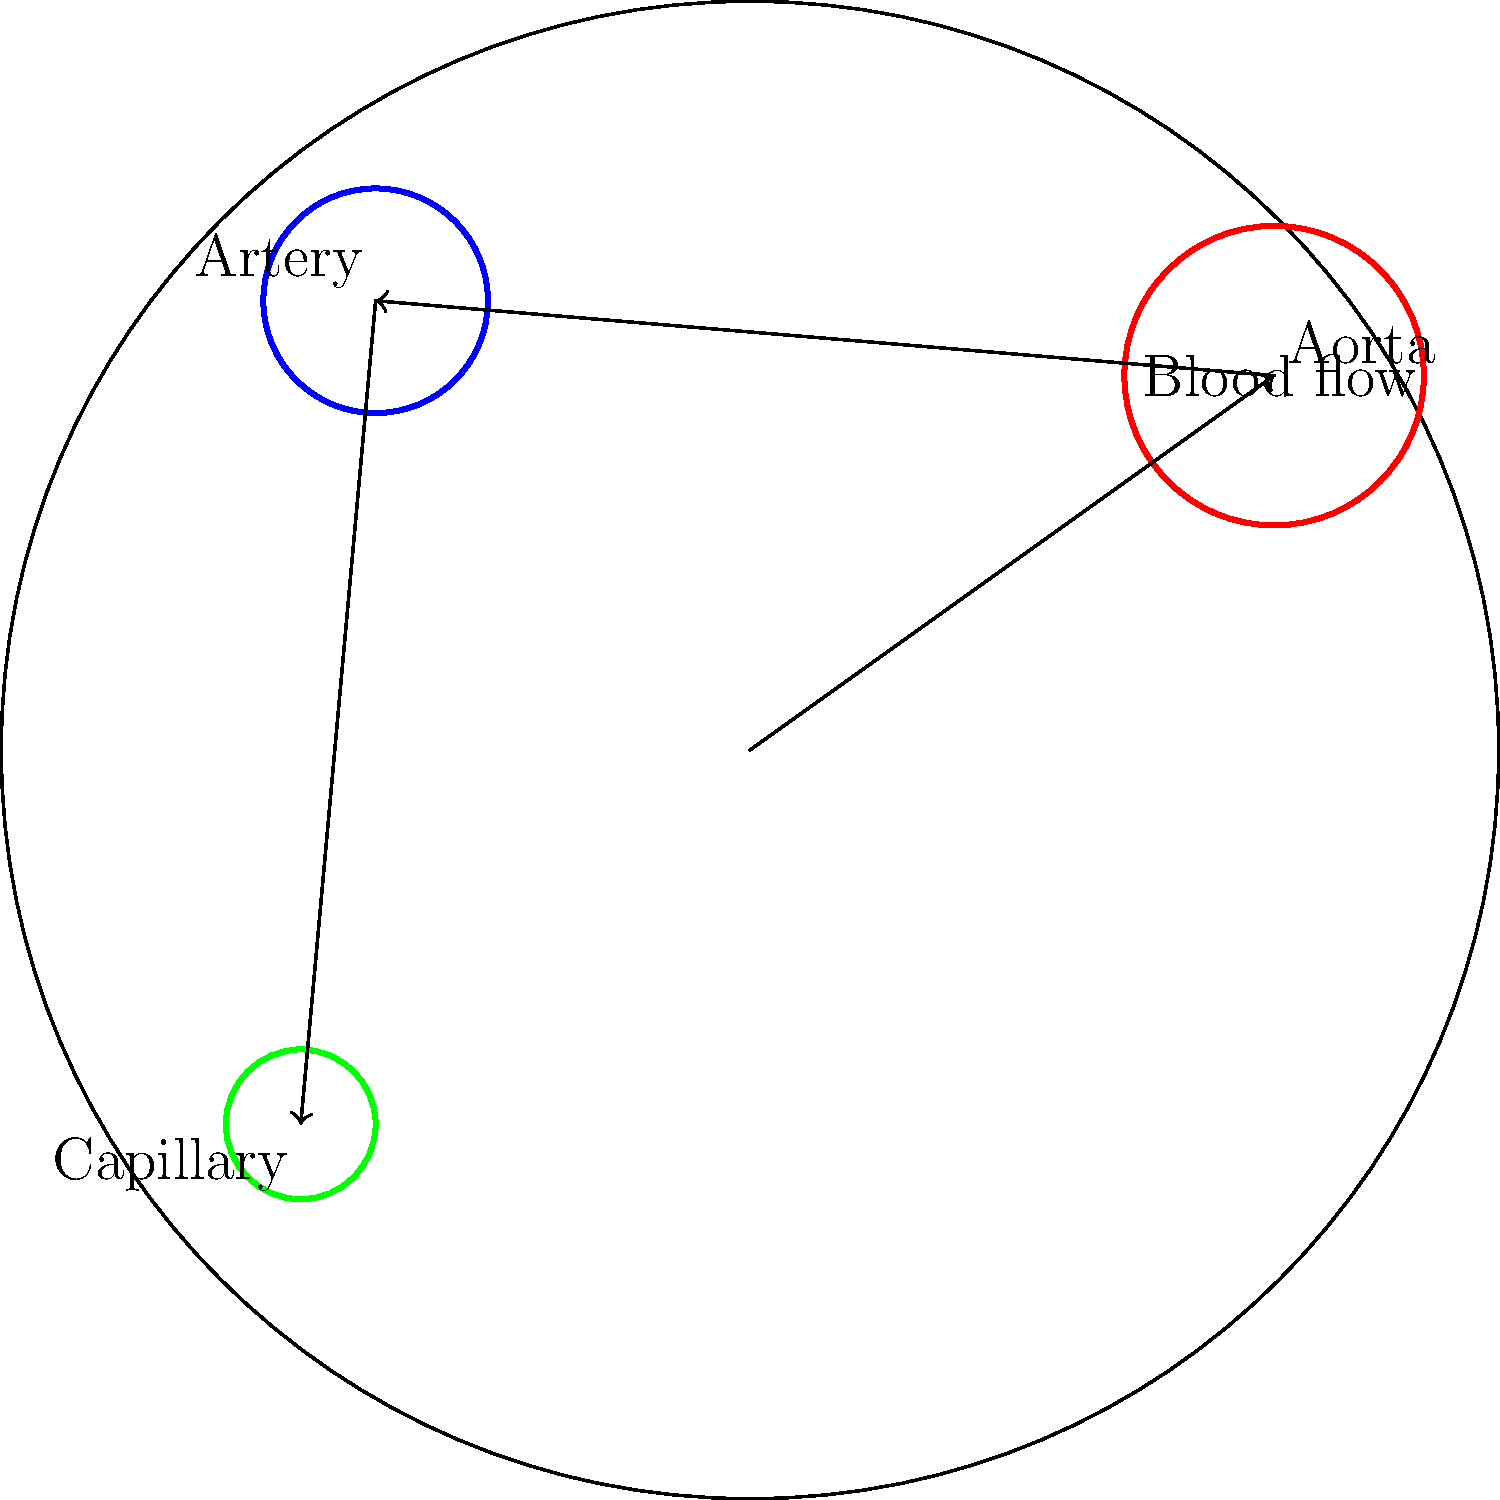In the circulatory system diagram above, blood flows from the aorta to arteries and then to capillaries. If the cross-sectional areas of these vessels are in the ratio of 16:4:1 respectively, how does the velocity of blood change as it moves through these vessels, assuming the same volume of blood passes through each vessel in a given time? To solve this problem, we'll use the principle of continuity in fluid dynamics:

1) The continuity equation states that for an incompressible fluid (like blood), the volume flow rate (Q) is constant:

   $Q = A_1v_1 = A_2v_2 = A_3v_3$

   Where A is the cross-sectional area and v is the velocity.

2) Given: The cross-sectional areas are in the ratio 16:4:1 for aorta:artery:capillary.
   Let's assign variables:
   $A_a$ : Area of aorta
   $A_r$ : Area of artery
   $A_c$ : Area of capillary

   $A_a : A_r : A_c = 16 : 4 : 1$

3) We can write:
   $A_r = \frac{1}{4}A_a$ and $A_c = \frac{1}{16}A_a$

4) Now, let's apply the continuity equation:
   $A_av_a = A_rv_r = A_cv_c$

5) Substituting the area ratios:
   $A_av_a = \frac{1}{4}A_av_r = \frac{1}{16}A_av_c$

6) Simplifying:
   $v_a = \frac{1}{4}v_r = \frac{1}{16}v_c$

7) This means:
   $v_r = 4v_a$ and $v_c = 16v_a$

8) Therefore, the velocity ratios are:
   $v_a : v_r : v_c = 1 : 4 : 16$

This shows that as blood moves from the aorta to arteries to capillaries, its velocity increases in the ratio 1:4:16.
Answer: The blood velocity increases in the ratio 1:4:16 from aorta to arteries to capillaries. 